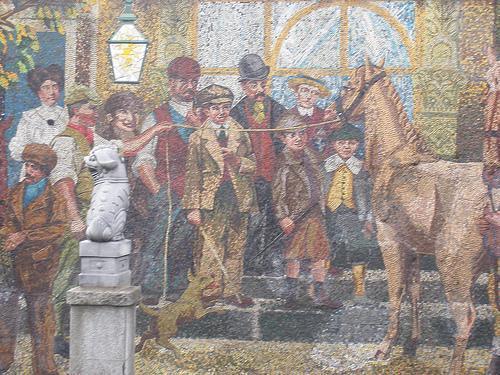How many hats are visible in the photo?
Give a very brief answer. 9. How many people are wearing hats?
Give a very brief answer. 9. 